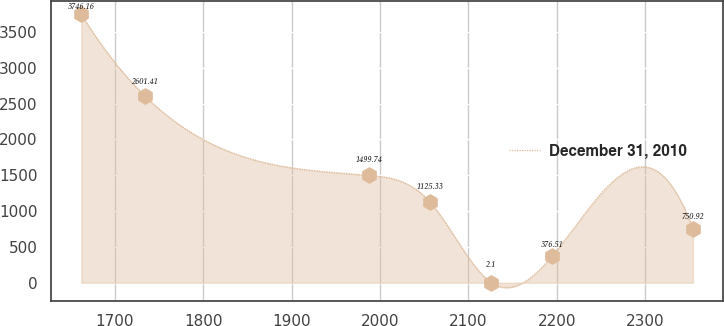Convert chart. <chart><loc_0><loc_0><loc_500><loc_500><line_chart><ecel><fcel>December 31, 2010<nl><fcel>1662.05<fcel>3746.16<nl><fcel>1734.49<fcel>2601.41<nl><fcel>1987.28<fcel>1499.74<nl><fcel>2056.46<fcel>1125.33<nl><fcel>2125.64<fcel>2.1<nl><fcel>2194.82<fcel>376.51<nl><fcel>2353.83<fcel>750.92<nl></chart> 